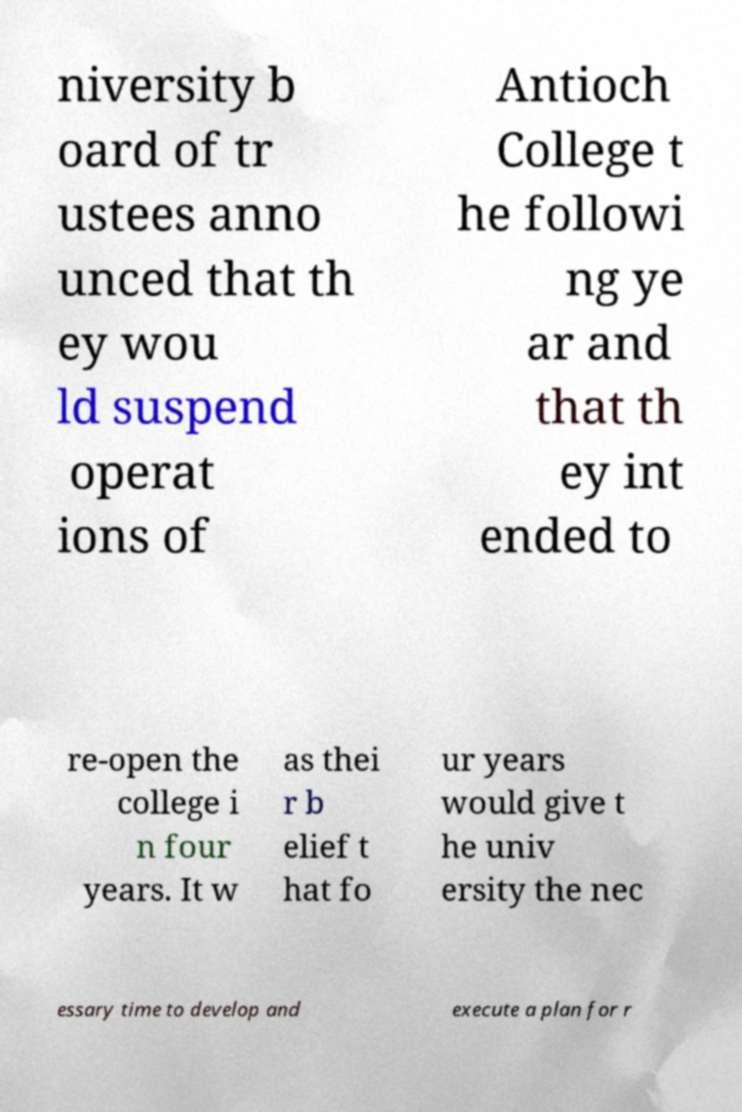Can you read and provide the text displayed in the image?This photo seems to have some interesting text. Can you extract and type it out for me? niversity b oard of tr ustees anno unced that th ey wou ld suspend operat ions of Antioch College t he followi ng ye ar and that th ey int ended to re-open the college i n four years. It w as thei r b elief t hat fo ur years would give t he univ ersity the nec essary time to develop and execute a plan for r 